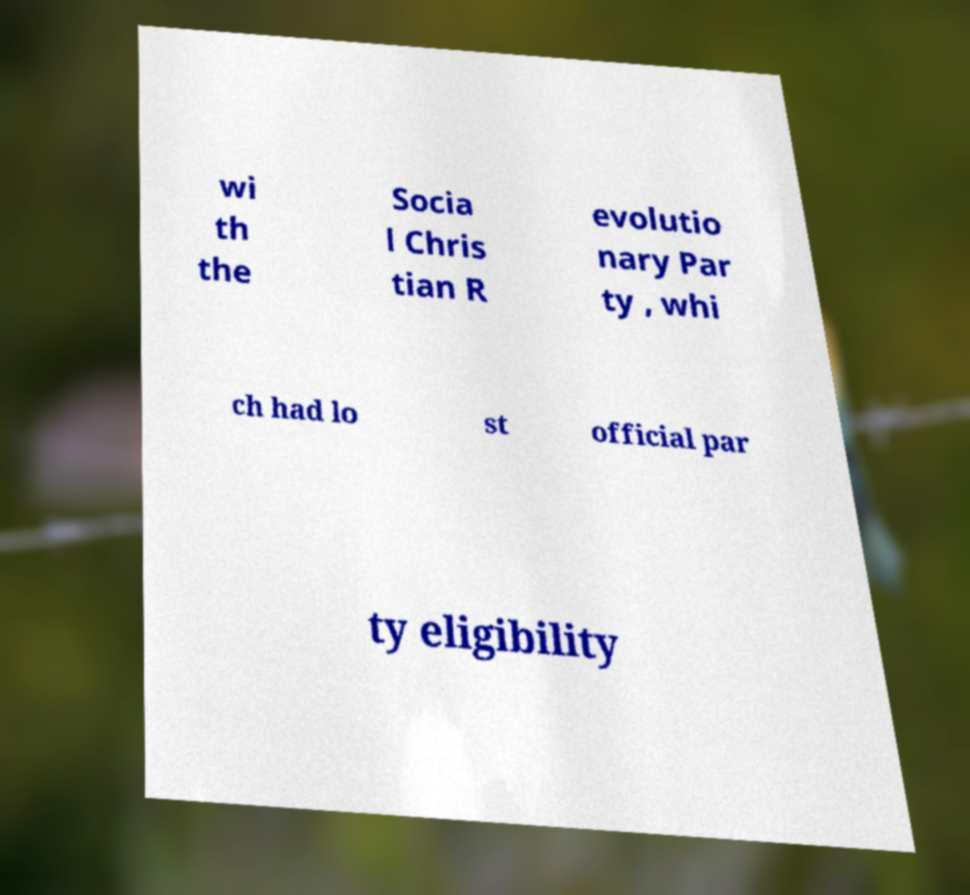I need the written content from this picture converted into text. Can you do that? wi th the Socia l Chris tian R evolutio nary Par ty , whi ch had lo st official par ty eligibility 